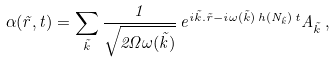<formula> <loc_0><loc_0><loc_500><loc_500>\alpha ( \vec { r } , t ) = \sum _ { \vec { k } } \frac { 1 } { \sqrt { 2 \Omega \omega ( \vec { k } ) } } \, e ^ { i \vec { k } . \vec { r } - i \omega ( \vec { k } ) \, h ( N _ { \vec { k } } ) \, t } A _ { \vec { k } } \, ,</formula> 